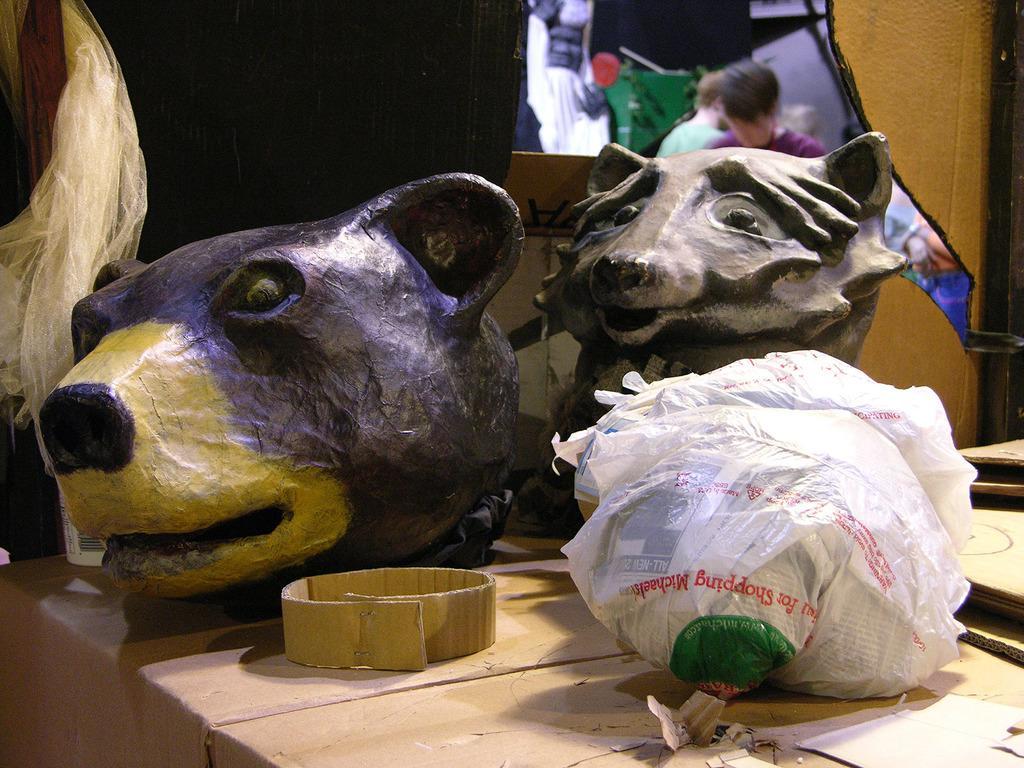How would you summarize this image in a sentence or two? In the center of the image we can see a depictions of animals on the table. In the background of the image there are persons. 